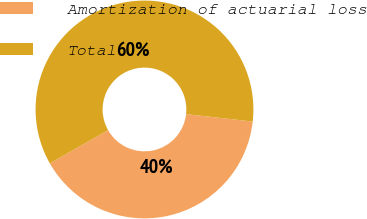Convert chart to OTSL. <chart><loc_0><loc_0><loc_500><loc_500><pie_chart><fcel>Amortization of actuarial loss<fcel>Total<nl><fcel>40.0%<fcel>60.0%<nl></chart> 